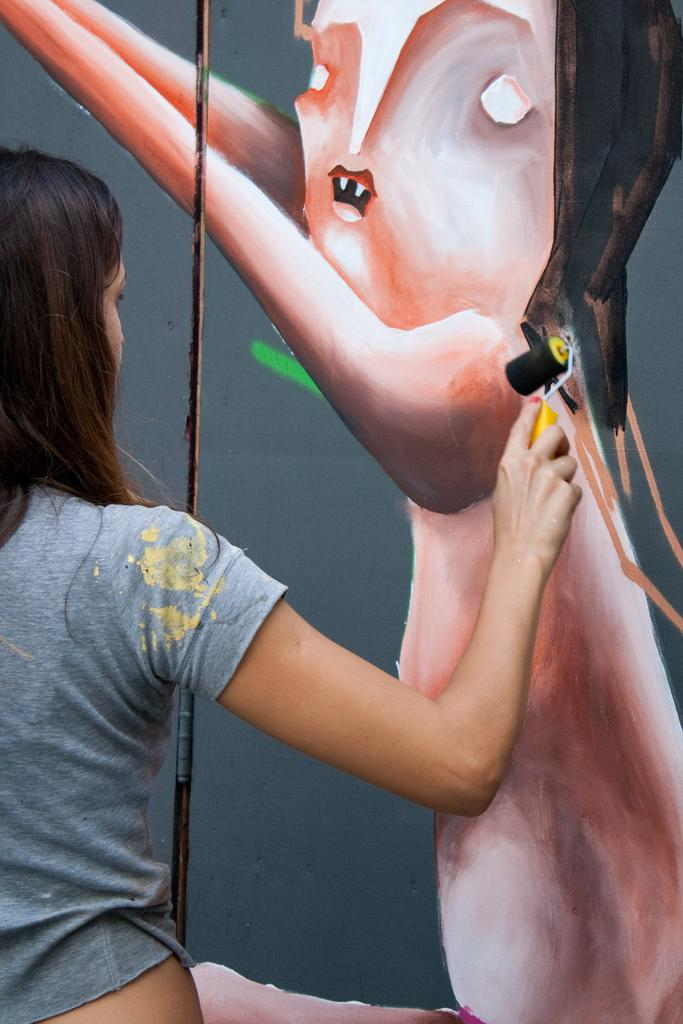What is the person in the image doing? The person is standing in the image and holding a paint roller. What might the person be doing with the paint roller? The person might be using the paint roller to paint the wall. Can you describe the painted wall in the image? There is a painted wall in the image. What type of curtain is hanging in front of the painted wall in the image? There is no curtain present in the image. How many tickets can be seen in the person's hand in the image? There are no tickets visible in the image. 